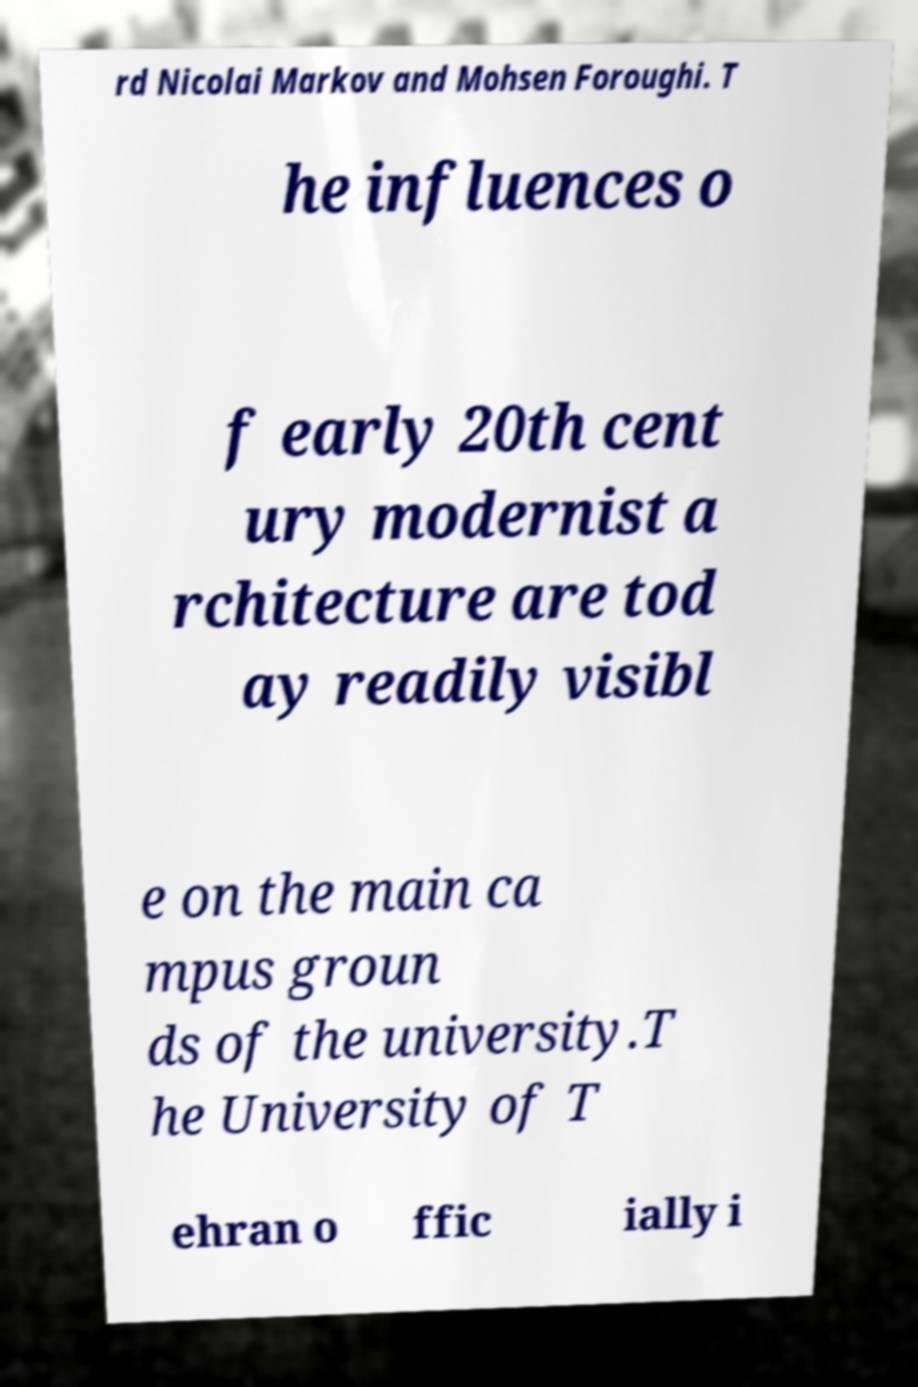There's text embedded in this image that I need extracted. Can you transcribe it verbatim? rd Nicolai Markov and Mohsen Foroughi. T he influences o f early 20th cent ury modernist a rchitecture are tod ay readily visibl e on the main ca mpus groun ds of the university.T he University of T ehran o ffic ially i 